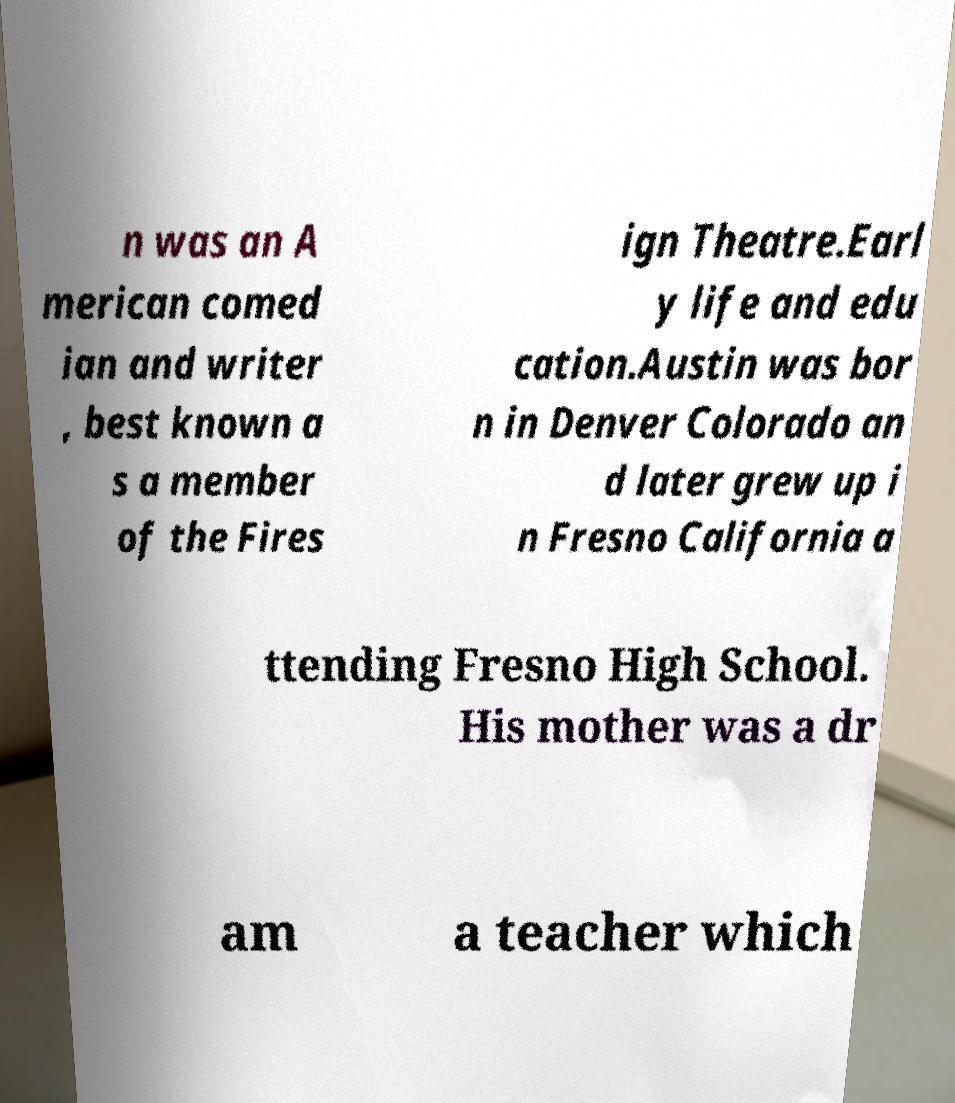For documentation purposes, I need the text within this image transcribed. Could you provide that? n was an A merican comed ian and writer , best known a s a member of the Fires ign Theatre.Earl y life and edu cation.Austin was bor n in Denver Colorado an d later grew up i n Fresno California a ttending Fresno High School. His mother was a dr am a teacher which 